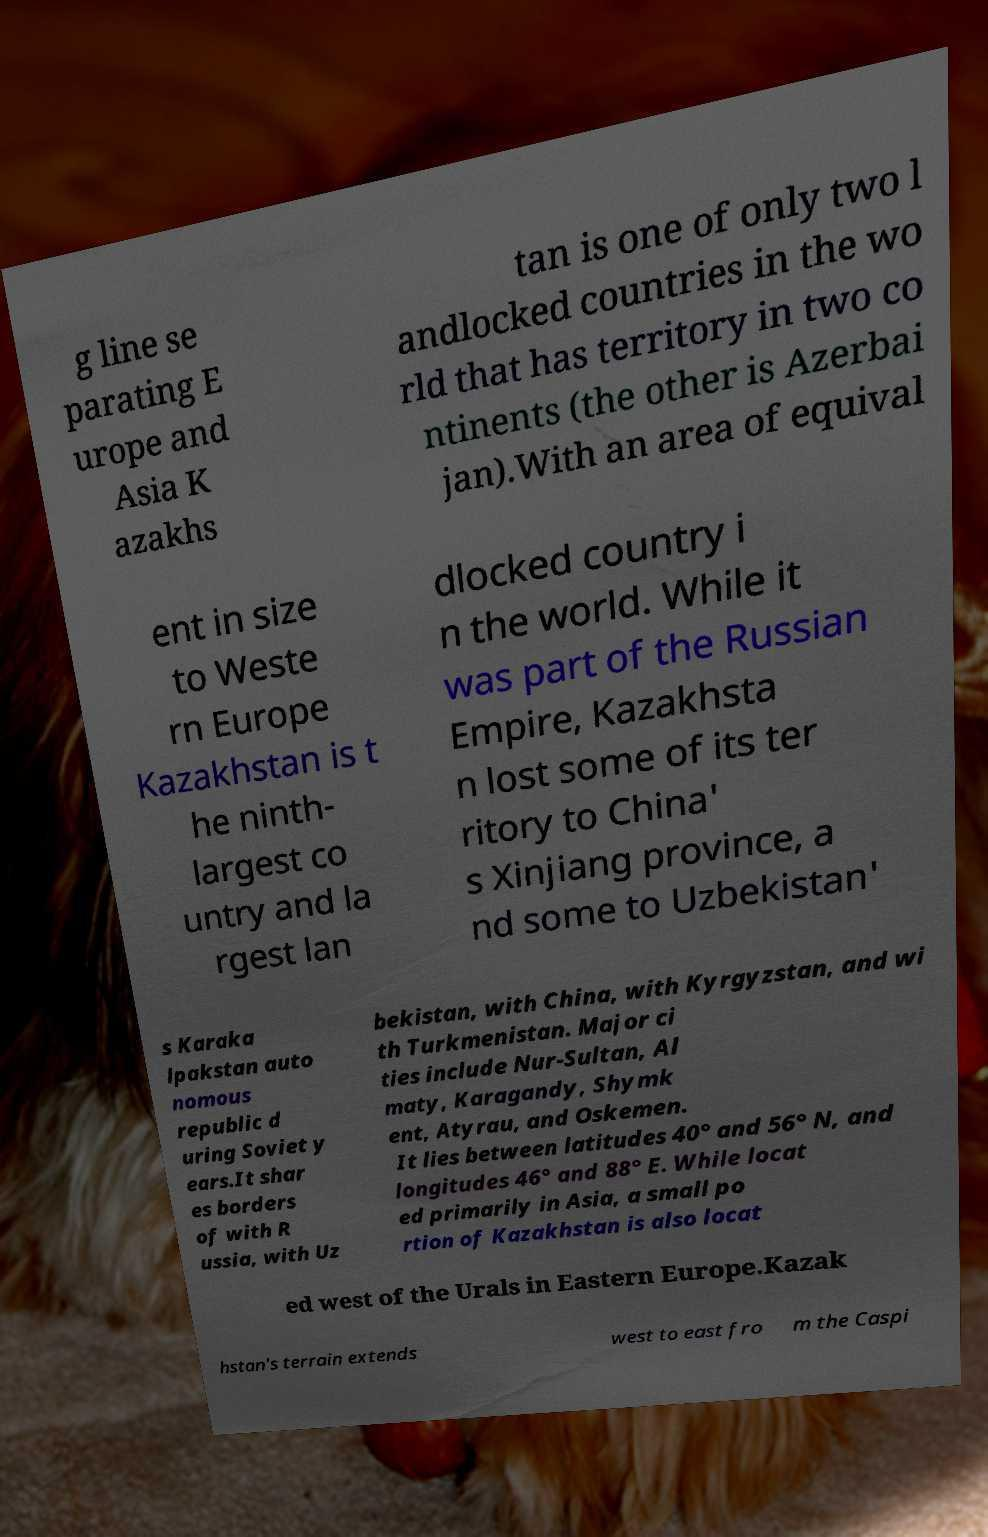What messages or text are displayed in this image? I need them in a readable, typed format. g line se parating E urope and Asia K azakhs tan is one of only two l andlocked countries in the wo rld that has territory in two co ntinents (the other is Azerbai jan).With an area of equival ent in size to Weste rn Europe Kazakhstan is t he ninth- largest co untry and la rgest lan dlocked country i n the world. While it was part of the Russian Empire, Kazakhsta n lost some of its ter ritory to China' s Xinjiang province, a nd some to Uzbekistan' s Karaka lpakstan auto nomous republic d uring Soviet y ears.It shar es borders of with R ussia, with Uz bekistan, with China, with Kyrgyzstan, and wi th Turkmenistan. Major ci ties include Nur-Sultan, Al maty, Karagandy, Shymk ent, Atyrau, and Oskemen. It lies between latitudes 40° and 56° N, and longitudes 46° and 88° E. While locat ed primarily in Asia, a small po rtion of Kazakhstan is also locat ed west of the Urals in Eastern Europe.Kazak hstan's terrain extends west to east fro m the Caspi 